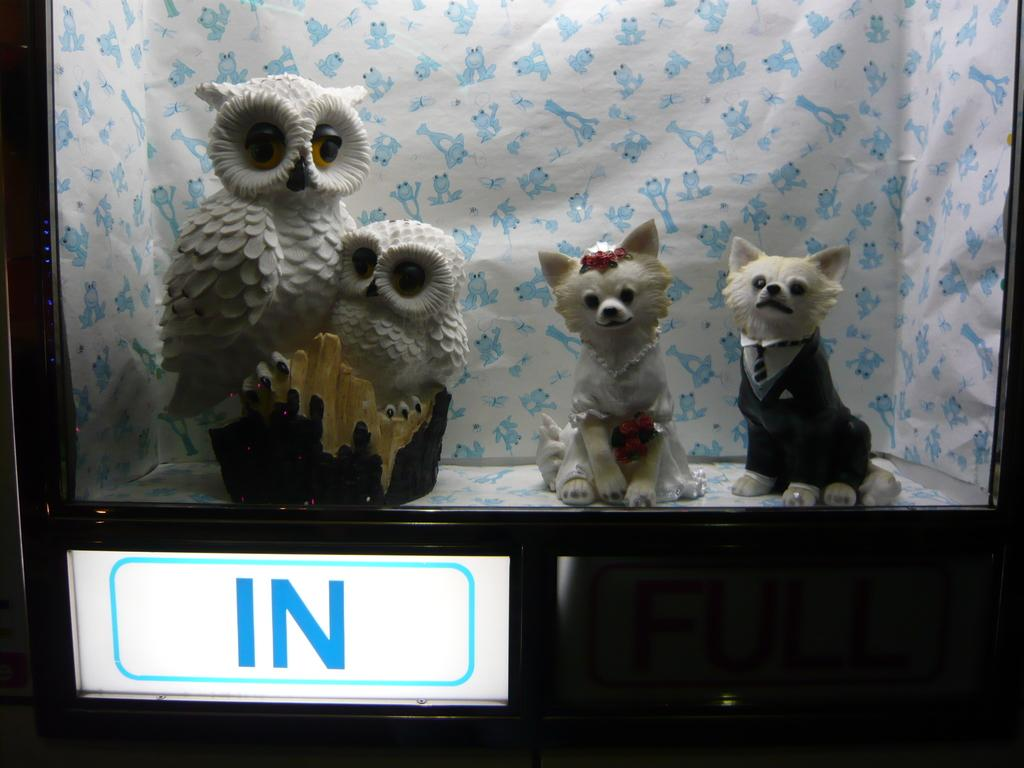What objects are placed on a platform in the image? There are toys placed on a platform in the image. What other object can be seen in the image? There is a board in the image. What can be seen in the background of the image? There is a cloth visible in the background of the image. What is the taste of the toys on the platform in the image? Toys do not have a taste, as they are inanimate objects. 